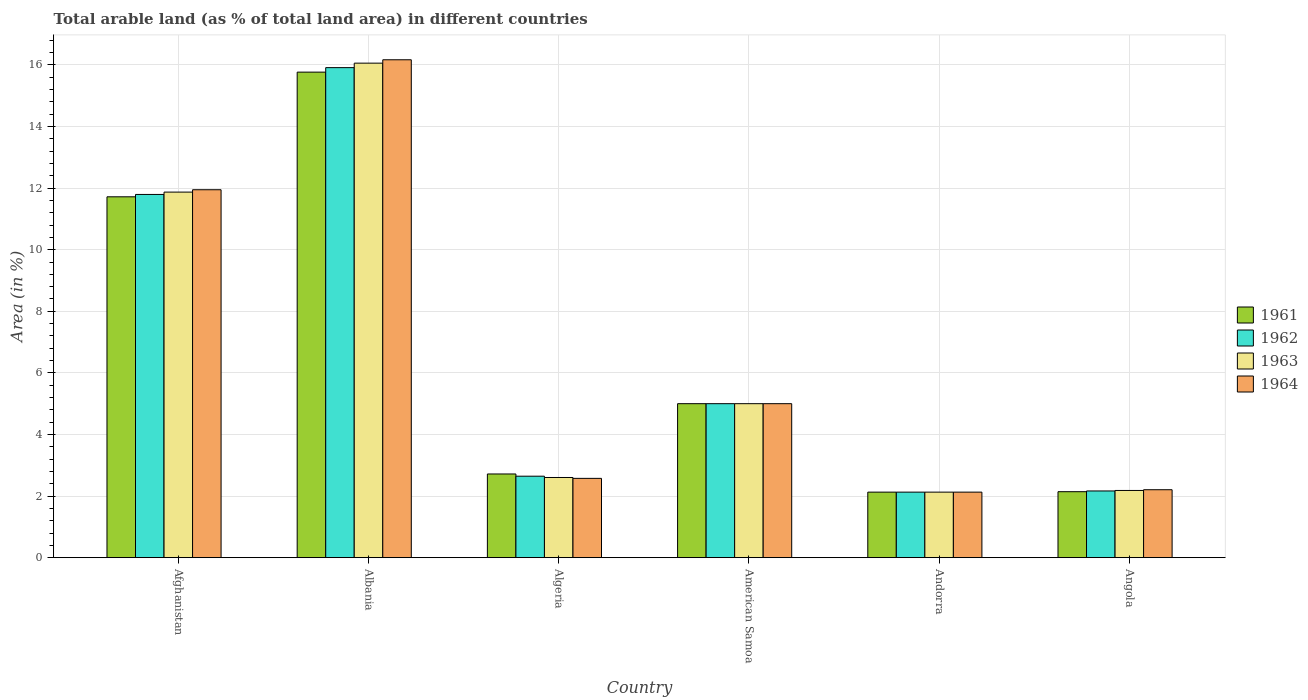How many different coloured bars are there?
Provide a succinct answer. 4. Are the number of bars per tick equal to the number of legend labels?
Give a very brief answer. Yes. How many bars are there on the 6th tick from the left?
Give a very brief answer. 4. How many bars are there on the 4th tick from the right?
Give a very brief answer. 4. What is the label of the 3rd group of bars from the left?
Your answer should be very brief. Algeria. What is the percentage of arable land in 1963 in Angola?
Make the answer very short. 2.18. Across all countries, what is the maximum percentage of arable land in 1962?
Give a very brief answer. 15.91. Across all countries, what is the minimum percentage of arable land in 1964?
Your response must be concise. 2.13. In which country was the percentage of arable land in 1962 maximum?
Offer a very short reply. Albania. In which country was the percentage of arable land in 1961 minimum?
Your answer should be very brief. Andorra. What is the total percentage of arable land in 1962 in the graph?
Provide a short and direct response. 39.65. What is the difference between the percentage of arable land in 1964 in Afghanistan and that in Angola?
Give a very brief answer. 9.74. What is the difference between the percentage of arable land in 1964 in Albania and the percentage of arable land in 1963 in American Samoa?
Give a very brief answer. 11.17. What is the average percentage of arable land in 1963 per country?
Your answer should be compact. 6.64. What is the difference between the percentage of arable land of/in 1964 and percentage of arable land of/in 1963 in Angola?
Ensure brevity in your answer.  0.02. What is the ratio of the percentage of arable land in 1964 in Afghanistan to that in American Samoa?
Keep it short and to the point. 2.39. Is the difference between the percentage of arable land in 1964 in Afghanistan and Andorra greater than the difference between the percentage of arable land in 1963 in Afghanistan and Andorra?
Ensure brevity in your answer.  Yes. What is the difference between the highest and the second highest percentage of arable land in 1962?
Your answer should be compact. 6.79. What is the difference between the highest and the lowest percentage of arable land in 1962?
Provide a succinct answer. 13.78. In how many countries, is the percentage of arable land in 1962 greater than the average percentage of arable land in 1962 taken over all countries?
Your answer should be very brief. 2. What does the 2nd bar from the left in Afghanistan represents?
Offer a terse response. 1962. What does the 1st bar from the right in American Samoa represents?
Ensure brevity in your answer.  1964. Are all the bars in the graph horizontal?
Your answer should be compact. No. What is the difference between two consecutive major ticks on the Y-axis?
Your response must be concise. 2. Are the values on the major ticks of Y-axis written in scientific E-notation?
Provide a succinct answer. No. Does the graph contain any zero values?
Offer a very short reply. No. Where does the legend appear in the graph?
Offer a terse response. Center right. What is the title of the graph?
Offer a very short reply. Total arable land (as % of total land area) in different countries. What is the label or title of the Y-axis?
Offer a very short reply. Area (in %). What is the Area (in %) in 1961 in Afghanistan?
Offer a very short reply. 11.72. What is the Area (in %) of 1962 in Afghanistan?
Ensure brevity in your answer.  11.79. What is the Area (in %) in 1963 in Afghanistan?
Keep it short and to the point. 11.87. What is the Area (in %) of 1964 in Afghanistan?
Offer a very short reply. 11.95. What is the Area (in %) in 1961 in Albania?
Your response must be concise. 15.77. What is the Area (in %) in 1962 in Albania?
Your answer should be very brief. 15.91. What is the Area (in %) in 1963 in Albania?
Your answer should be compact. 16.06. What is the Area (in %) of 1964 in Albania?
Provide a succinct answer. 16.17. What is the Area (in %) in 1961 in Algeria?
Keep it short and to the point. 2.72. What is the Area (in %) in 1962 in Algeria?
Provide a succinct answer. 2.65. What is the Area (in %) in 1963 in Algeria?
Provide a short and direct response. 2.6. What is the Area (in %) of 1964 in Algeria?
Offer a very short reply. 2.57. What is the Area (in %) in 1962 in American Samoa?
Your answer should be compact. 5. What is the Area (in %) of 1963 in American Samoa?
Make the answer very short. 5. What is the Area (in %) in 1961 in Andorra?
Your answer should be very brief. 2.13. What is the Area (in %) in 1962 in Andorra?
Your response must be concise. 2.13. What is the Area (in %) in 1963 in Andorra?
Your answer should be compact. 2.13. What is the Area (in %) in 1964 in Andorra?
Give a very brief answer. 2.13. What is the Area (in %) in 1961 in Angola?
Give a very brief answer. 2.14. What is the Area (in %) in 1962 in Angola?
Provide a short and direct response. 2.17. What is the Area (in %) of 1963 in Angola?
Provide a succinct answer. 2.18. What is the Area (in %) in 1964 in Angola?
Give a very brief answer. 2.21. Across all countries, what is the maximum Area (in %) of 1961?
Ensure brevity in your answer.  15.77. Across all countries, what is the maximum Area (in %) in 1962?
Offer a terse response. 15.91. Across all countries, what is the maximum Area (in %) of 1963?
Keep it short and to the point. 16.06. Across all countries, what is the maximum Area (in %) of 1964?
Offer a terse response. 16.17. Across all countries, what is the minimum Area (in %) in 1961?
Keep it short and to the point. 2.13. Across all countries, what is the minimum Area (in %) in 1962?
Your answer should be very brief. 2.13. Across all countries, what is the minimum Area (in %) of 1963?
Keep it short and to the point. 2.13. Across all countries, what is the minimum Area (in %) in 1964?
Make the answer very short. 2.13. What is the total Area (in %) of 1961 in the graph?
Offer a terse response. 39.47. What is the total Area (in %) in 1962 in the graph?
Ensure brevity in your answer.  39.65. What is the total Area (in %) in 1963 in the graph?
Provide a short and direct response. 39.84. What is the total Area (in %) in 1964 in the graph?
Give a very brief answer. 40.02. What is the difference between the Area (in %) in 1961 in Afghanistan and that in Albania?
Your answer should be very brief. -4.05. What is the difference between the Area (in %) in 1962 in Afghanistan and that in Albania?
Offer a very short reply. -4.12. What is the difference between the Area (in %) in 1963 in Afghanistan and that in Albania?
Provide a short and direct response. -4.19. What is the difference between the Area (in %) of 1964 in Afghanistan and that in Albania?
Provide a short and direct response. -4.22. What is the difference between the Area (in %) in 1961 in Afghanistan and that in Algeria?
Give a very brief answer. 9. What is the difference between the Area (in %) in 1962 in Afghanistan and that in Algeria?
Ensure brevity in your answer.  9.15. What is the difference between the Area (in %) of 1963 in Afghanistan and that in Algeria?
Keep it short and to the point. 9.27. What is the difference between the Area (in %) in 1964 in Afghanistan and that in Algeria?
Offer a very short reply. 9.37. What is the difference between the Area (in %) in 1961 in Afghanistan and that in American Samoa?
Offer a very short reply. 6.72. What is the difference between the Area (in %) in 1962 in Afghanistan and that in American Samoa?
Provide a short and direct response. 6.79. What is the difference between the Area (in %) in 1963 in Afghanistan and that in American Samoa?
Give a very brief answer. 6.87. What is the difference between the Area (in %) of 1964 in Afghanistan and that in American Samoa?
Keep it short and to the point. 6.95. What is the difference between the Area (in %) of 1961 in Afghanistan and that in Andorra?
Your answer should be very brief. 9.59. What is the difference between the Area (in %) of 1962 in Afghanistan and that in Andorra?
Give a very brief answer. 9.67. What is the difference between the Area (in %) of 1963 in Afghanistan and that in Andorra?
Give a very brief answer. 9.74. What is the difference between the Area (in %) in 1964 in Afghanistan and that in Andorra?
Make the answer very short. 9.82. What is the difference between the Area (in %) of 1961 in Afghanistan and that in Angola?
Your answer should be very brief. 9.58. What is the difference between the Area (in %) of 1962 in Afghanistan and that in Angola?
Provide a succinct answer. 9.63. What is the difference between the Area (in %) of 1963 in Afghanistan and that in Angola?
Provide a succinct answer. 9.69. What is the difference between the Area (in %) in 1964 in Afghanistan and that in Angola?
Your answer should be very brief. 9.74. What is the difference between the Area (in %) of 1961 in Albania and that in Algeria?
Provide a succinct answer. 13.05. What is the difference between the Area (in %) in 1962 in Albania and that in Algeria?
Give a very brief answer. 13.27. What is the difference between the Area (in %) of 1963 in Albania and that in Algeria?
Provide a succinct answer. 13.46. What is the difference between the Area (in %) of 1964 in Albania and that in Algeria?
Offer a very short reply. 13.59. What is the difference between the Area (in %) in 1961 in Albania and that in American Samoa?
Provide a short and direct response. 10.77. What is the difference between the Area (in %) of 1962 in Albania and that in American Samoa?
Offer a very short reply. 10.91. What is the difference between the Area (in %) of 1963 in Albania and that in American Samoa?
Give a very brief answer. 11.06. What is the difference between the Area (in %) in 1964 in Albania and that in American Samoa?
Offer a very short reply. 11.17. What is the difference between the Area (in %) in 1961 in Albania and that in Andorra?
Offer a very short reply. 13.64. What is the difference between the Area (in %) of 1962 in Albania and that in Andorra?
Your answer should be very brief. 13.78. What is the difference between the Area (in %) of 1963 in Albania and that in Andorra?
Your answer should be compact. 13.93. What is the difference between the Area (in %) of 1964 in Albania and that in Andorra?
Offer a terse response. 14.04. What is the difference between the Area (in %) of 1961 in Albania and that in Angola?
Give a very brief answer. 13.62. What is the difference between the Area (in %) of 1962 in Albania and that in Angola?
Your response must be concise. 13.75. What is the difference between the Area (in %) of 1963 in Albania and that in Angola?
Your response must be concise. 13.88. What is the difference between the Area (in %) of 1964 in Albania and that in Angola?
Provide a succinct answer. 13.96. What is the difference between the Area (in %) in 1961 in Algeria and that in American Samoa?
Your response must be concise. -2.28. What is the difference between the Area (in %) of 1962 in Algeria and that in American Samoa?
Keep it short and to the point. -2.35. What is the difference between the Area (in %) of 1963 in Algeria and that in American Samoa?
Offer a terse response. -2.4. What is the difference between the Area (in %) of 1964 in Algeria and that in American Samoa?
Your answer should be compact. -2.43. What is the difference between the Area (in %) of 1961 in Algeria and that in Andorra?
Keep it short and to the point. 0.59. What is the difference between the Area (in %) of 1962 in Algeria and that in Andorra?
Provide a short and direct response. 0.52. What is the difference between the Area (in %) of 1963 in Algeria and that in Andorra?
Make the answer very short. 0.48. What is the difference between the Area (in %) of 1964 in Algeria and that in Andorra?
Your response must be concise. 0.45. What is the difference between the Area (in %) in 1961 in Algeria and that in Angola?
Provide a short and direct response. 0.58. What is the difference between the Area (in %) of 1962 in Algeria and that in Angola?
Your answer should be compact. 0.48. What is the difference between the Area (in %) in 1963 in Algeria and that in Angola?
Offer a very short reply. 0.42. What is the difference between the Area (in %) of 1964 in Algeria and that in Angola?
Offer a terse response. 0.37. What is the difference between the Area (in %) in 1961 in American Samoa and that in Andorra?
Make the answer very short. 2.87. What is the difference between the Area (in %) of 1962 in American Samoa and that in Andorra?
Offer a terse response. 2.87. What is the difference between the Area (in %) in 1963 in American Samoa and that in Andorra?
Ensure brevity in your answer.  2.87. What is the difference between the Area (in %) of 1964 in American Samoa and that in Andorra?
Your answer should be very brief. 2.87. What is the difference between the Area (in %) in 1961 in American Samoa and that in Angola?
Make the answer very short. 2.86. What is the difference between the Area (in %) in 1962 in American Samoa and that in Angola?
Your response must be concise. 2.83. What is the difference between the Area (in %) in 1963 in American Samoa and that in Angola?
Offer a very short reply. 2.82. What is the difference between the Area (in %) of 1964 in American Samoa and that in Angola?
Make the answer very short. 2.79. What is the difference between the Area (in %) in 1961 in Andorra and that in Angola?
Provide a succinct answer. -0.01. What is the difference between the Area (in %) in 1962 in Andorra and that in Angola?
Your answer should be compact. -0.04. What is the difference between the Area (in %) in 1963 in Andorra and that in Angola?
Make the answer very short. -0.05. What is the difference between the Area (in %) of 1964 in Andorra and that in Angola?
Give a very brief answer. -0.08. What is the difference between the Area (in %) in 1961 in Afghanistan and the Area (in %) in 1962 in Albania?
Keep it short and to the point. -4.19. What is the difference between the Area (in %) in 1961 in Afghanistan and the Area (in %) in 1963 in Albania?
Make the answer very short. -4.34. What is the difference between the Area (in %) in 1961 in Afghanistan and the Area (in %) in 1964 in Albania?
Your answer should be very brief. -4.45. What is the difference between the Area (in %) in 1962 in Afghanistan and the Area (in %) in 1963 in Albania?
Keep it short and to the point. -4.26. What is the difference between the Area (in %) of 1962 in Afghanistan and the Area (in %) of 1964 in Albania?
Provide a short and direct response. -4.37. What is the difference between the Area (in %) in 1963 in Afghanistan and the Area (in %) in 1964 in Albania?
Your response must be concise. -4.3. What is the difference between the Area (in %) of 1961 in Afghanistan and the Area (in %) of 1962 in Algeria?
Provide a short and direct response. 9.07. What is the difference between the Area (in %) in 1961 in Afghanistan and the Area (in %) in 1963 in Algeria?
Make the answer very short. 9.11. What is the difference between the Area (in %) of 1961 in Afghanistan and the Area (in %) of 1964 in Algeria?
Your answer should be very brief. 9.14. What is the difference between the Area (in %) of 1962 in Afghanistan and the Area (in %) of 1963 in Algeria?
Offer a terse response. 9.19. What is the difference between the Area (in %) in 1962 in Afghanistan and the Area (in %) in 1964 in Algeria?
Make the answer very short. 9.22. What is the difference between the Area (in %) of 1963 in Afghanistan and the Area (in %) of 1964 in Algeria?
Keep it short and to the point. 9.3. What is the difference between the Area (in %) in 1961 in Afghanistan and the Area (in %) in 1962 in American Samoa?
Offer a terse response. 6.72. What is the difference between the Area (in %) of 1961 in Afghanistan and the Area (in %) of 1963 in American Samoa?
Offer a terse response. 6.72. What is the difference between the Area (in %) of 1961 in Afghanistan and the Area (in %) of 1964 in American Samoa?
Provide a short and direct response. 6.72. What is the difference between the Area (in %) of 1962 in Afghanistan and the Area (in %) of 1963 in American Samoa?
Your answer should be very brief. 6.79. What is the difference between the Area (in %) of 1962 in Afghanistan and the Area (in %) of 1964 in American Samoa?
Your answer should be very brief. 6.79. What is the difference between the Area (in %) of 1963 in Afghanistan and the Area (in %) of 1964 in American Samoa?
Make the answer very short. 6.87. What is the difference between the Area (in %) in 1961 in Afghanistan and the Area (in %) in 1962 in Andorra?
Ensure brevity in your answer.  9.59. What is the difference between the Area (in %) in 1961 in Afghanistan and the Area (in %) in 1963 in Andorra?
Ensure brevity in your answer.  9.59. What is the difference between the Area (in %) in 1961 in Afghanistan and the Area (in %) in 1964 in Andorra?
Your answer should be compact. 9.59. What is the difference between the Area (in %) in 1962 in Afghanistan and the Area (in %) in 1963 in Andorra?
Offer a terse response. 9.67. What is the difference between the Area (in %) in 1962 in Afghanistan and the Area (in %) in 1964 in Andorra?
Make the answer very short. 9.67. What is the difference between the Area (in %) in 1963 in Afghanistan and the Area (in %) in 1964 in Andorra?
Offer a terse response. 9.74. What is the difference between the Area (in %) in 1961 in Afghanistan and the Area (in %) in 1962 in Angola?
Provide a succinct answer. 9.55. What is the difference between the Area (in %) in 1961 in Afghanistan and the Area (in %) in 1963 in Angola?
Your answer should be compact. 9.54. What is the difference between the Area (in %) in 1961 in Afghanistan and the Area (in %) in 1964 in Angola?
Your answer should be very brief. 9.51. What is the difference between the Area (in %) of 1962 in Afghanistan and the Area (in %) of 1963 in Angola?
Your answer should be compact. 9.61. What is the difference between the Area (in %) in 1962 in Afghanistan and the Area (in %) in 1964 in Angola?
Keep it short and to the point. 9.59. What is the difference between the Area (in %) of 1963 in Afghanistan and the Area (in %) of 1964 in Angola?
Your answer should be very brief. 9.66. What is the difference between the Area (in %) in 1961 in Albania and the Area (in %) in 1962 in Algeria?
Provide a short and direct response. 13.12. What is the difference between the Area (in %) in 1961 in Albania and the Area (in %) in 1963 in Algeria?
Offer a terse response. 13.16. What is the difference between the Area (in %) of 1961 in Albania and the Area (in %) of 1964 in Algeria?
Provide a short and direct response. 13.19. What is the difference between the Area (in %) in 1962 in Albania and the Area (in %) in 1963 in Algeria?
Your response must be concise. 13.31. What is the difference between the Area (in %) of 1962 in Albania and the Area (in %) of 1964 in Algeria?
Your answer should be very brief. 13.34. What is the difference between the Area (in %) of 1963 in Albania and the Area (in %) of 1964 in Algeria?
Keep it short and to the point. 13.48. What is the difference between the Area (in %) in 1961 in Albania and the Area (in %) in 1962 in American Samoa?
Your answer should be very brief. 10.77. What is the difference between the Area (in %) in 1961 in Albania and the Area (in %) in 1963 in American Samoa?
Your response must be concise. 10.77. What is the difference between the Area (in %) in 1961 in Albania and the Area (in %) in 1964 in American Samoa?
Keep it short and to the point. 10.77. What is the difference between the Area (in %) of 1962 in Albania and the Area (in %) of 1963 in American Samoa?
Ensure brevity in your answer.  10.91. What is the difference between the Area (in %) of 1962 in Albania and the Area (in %) of 1964 in American Samoa?
Make the answer very short. 10.91. What is the difference between the Area (in %) in 1963 in Albania and the Area (in %) in 1964 in American Samoa?
Provide a short and direct response. 11.06. What is the difference between the Area (in %) of 1961 in Albania and the Area (in %) of 1962 in Andorra?
Your answer should be very brief. 13.64. What is the difference between the Area (in %) of 1961 in Albania and the Area (in %) of 1963 in Andorra?
Your answer should be very brief. 13.64. What is the difference between the Area (in %) in 1961 in Albania and the Area (in %) in 1964 in Andorra?
Provide a short and direct response. 13.64. What is the difference between the Area (in %) of 1962 in Albania and the Area (in %) of 1963 in Andorra?
Keep it short and to the point. 13.78. What is the difference between the Area (in %) in 1962 in Albania and the Area (in %) in 1964 in Andorra?
Ensure brevity in your answer.  13.78. What is the difference between the Area (in %) of 1963 in Albania and the Area (in %) of 1964 in Andorra?
Your answer should be very brief. 13.93. What is the difference between the Area (in %) of 1961 in Albania and the Area (in %) of 1962 in Angola?
Provide a succinct answer. 13.6. What is the difference between the Area (in %) of 1961 in Albania and the Area (in %) of 1963 in Angola?
Keep it short and to the point. 13.58. What is the difference between the Area (in %) in 1961 in Albania and the Area (in %) in 1964 in Angola?
Give a very brief answer. 13.56. What is the difference between the Area (in %) of 1962 in Albania and the Area (in %) of 1963 in Angola?
Keep it short and to the point. 13.73. What is the difference between the Area (in %) in 1962 in Albania and the Area (in %) in 1964 in Angola?
Give a very brief answer. 13.71. What is the difference between the Area (in %) of 1963 in Albania and the Area (in %) of 1964 in Angola?
Offer a terse response. 13.85. What is the difference between the Area (in %) of 1961 in Algeria and the Area (in %) of 1962 in American Samoa?
Keep it short and to the point. -2.28. What is the difference between the Area (in %) in 1961 in Algeria and the Area (in %) in 1963 in American Samoa?
Keep it short and to the point. -2.28. What is the difference between the Area (in %) of 1961 in Algeria and the Area (in %) of 1964 in American Samoa?
Provide a short and direct response. -2.28. What is the difference between the Area (in %) in 1962 in Algeria and the Area (in %) in 1963 in American Samoa?
Your response must be concise. -2.35. What is the difference between the Area (in %) of 1962 in Algeria and the Area (in %) of 1964 in American Samoa?
Give a very brief answer. -2.35. What is the difference between the Area (in %) of 1963 in Algeria and the Area (in %) of 1964 in American Samoa?
Offer a very short reply. -2.4. What is the difference between the Area (in %) in 1961 in Algeria and the Area (in %) in 1962 in Andorra?
Provide a succinct answer. 0.59. What is the difference between the Area (in %) in 1961 in Algeria and the Area (in %) in 1963 in Andorra?
Give a very brief answer. 0.59. What is the difference between the Area (in %) of 1961 in Algeria and the Area (in %) of 1964 in Andorra?
Your response must be concise. 0.59. What is the difference between the Area (in %) of 1962 in Algeria and the Area (in %) of 1963 in Andorra?
Keep it short and to the point. 0.52. What is the difference between the Area (in %) of 1962 in Algeria and the Area (in %) of 1964 in Andorra?
Offer a terse response. 0.52. What is the difference between the Area (in %) of 1963 in Algeria and the Area (in %) of 1964 in Andorra?
Give a very brief answer. 0.48. What is the difference between the Area (in %) of 1961 in Algeria and the Area (in %) of 1962 in Angola?
Ensure brevity in your answer.  0.55. What is the difference between the Area (in %) of 1961 in Algeria and the Area (in %) of 1963 in Angola?
Provide a short and direct response. 0.54. What is the difference between the Area (in %) in 1961 in Algeria and the Area (in %) in 1964 in Angola?
Keep it short and to the point. 0.51. What is the difference between the Area (in %) in 1962 in Algeria and the Area (in %) in 1963 in Angola?
Provide a short and direct response. 0.46. What is the difference between the Area (in %) in 1962 in Algeria and the Area (in %) in 1964 in Angola?
Ensure brevity in your answer.  0.44. What is the difference between the Area (in %) of 1963 in Algeria and the Area (in %) of 1964 in Angola?
Keep it short and to the point. 0.4. What is the difference between the Area (in %) in 1961 in American Samoa and the Area (in %) in 1962 in Andorra?
Offer a very short reply. 2.87. What is the difference between the Area (in %) of 1961 in American Samoa and the Area (in %) of 1963 in Andorra?
Provide a short and direct response. 2.87. What is the difference between the Area (in %) of 1961 in American Samoa and the Area (in %) of 1964 in Andorra?
Your response must be concise. 2.87. What is the difference between the Area (in %) in 1962 in American Samoa and the Area (in %) in 1963 in Andorra?
Your answer should be very brief. 2.87. What is the difference between the Area (in %) of 1962 in American Samoa and the Area (in %) of 1964 in Andorra?
Keep it short and to the point. 2.87. What is the difference between the Area (in %) of 1963 in American Samoa and the Area (in %) of 1964 in Andorra?
Your answer should be compact. 2.87. What is the difference between the Area (in %) in 1961 in American Samoa and the Area (in %) in 1962 in Angola?
Offer a very short reply. 2.83. What is the difference between the Area (in %) of 1961 in American Samoa and the Area (in %) of 1963 in Angola?
Give a very brief answer. 2.82. What is the difference between the Area (in %) of 1961 in American Samoa and the Area (in %) of 1964 in Angola?
Your response must be concise. 2.79. What is the difference between the Area (in %) of 1962 in American Samoa and the Area (in %) of 1963 in Angola?
Keep it short and to the point. 2.82. What is the difference between the Area (in %) of 1962 in American Samoa and the Area (in %) of 1964 in Angola?
Provide a succinct answer. 2.79. What is the difference between the Area (in %) of 1963 in American Samoa and the Area (in %) of 1964 in Angola?
Offer a very short reply. 2.79. What is the difference between the Area (in %) in 1961 in Andorra and the Area (in %) in 1962 in Angola?
Make the answer very short. -0.04. What is the difference between the Area (in %) of 1961 in Andorra and the Area (in %) of 1963 in Angola?
Give a very brief answer. -0.05. What is the difference between the Area (in %) in 1961 in Andorra and the Area (in %) in 1964 in Angola?
Offer a terse response. -0.08. What is the difference between the Area (in %) of 1962 in Andorra and the Area (in %) of 1963 in Angola?
Provide a short and direct response. -0.05. What is the difference between the Area (in %) of 1962 in Andorra and the Area (in %) of 1964 in Angola?
Your answer should be compact. -0.08. What is the difference between the Area (in %) in 1963 in Andorra and the Area (in %) in 1964 in Angola?
Offer a terse response. -0.08. What is the average Area (in %) in 1961 per country?
Give a very brief answer. 6.58. What is the average Area (in %) in 1962 per country?
Provide a short and direct response. 6.61. What is the average Area (in %) in 1963 per country?
Offer a very short reply. 6.64. What is the average Area (in %) in 1964 per country?
Keep it short and to the point. 6.67. What is the difference between the Area (in %) of 1961 and Area (in %) of 1962 in Afghanistan?
Give a very brief answer. -0.08. What is the difference between the Area (in %) in 1961 and Area (in %) in 1963 in Afghanistan?
Offer a very short reply. -0.15. What is the difference between the Area (in %) of 1961 and Area (in %) of 1964 in Afghanistan?
Keep it short and to the point. -0.23. What is the difference between the Area (in %) in 1962 and Area (in %) in 1963 in Afghanistan?
Give a very brief answer. -0.08. What is the difference between the Area (in %) of 1962 and Area (in %) of 1964 in Afghanistan?
Provide a succinct answer. -0.15. What is the difference between the Area (in %) of 1963 and Area (in %) of 1964 in Afghanistan?
Your answer should be compact. -0.08. What is the difference between the Area (in %) of 1961 and Area (in %) of 1962 in Albania?
Your response must be concise. -0.15. What is the difference between the Area (in %) in 1961 and Area (in %) in 1963 in Albania?
Ensure brevity in your answer.  -0.29. What is the difference between the Area (in %) in 1961 and Area (in %) in 1964 in Albania?
Provide a short and direct response. -0.4. What is the difference between the Area (in %) of 1962 and Area (in %) of 1963 in Albania?
Your response must be concise. -0.15. What is the difference between the Area (in %) of 1962 and Area (in %) of 1964 in Albania?
Make the answer very short. -0.26. What is the difference between the Area (in %) in 1963 and Area (in %) in 1964 in Albania?
Make the answer very short. -0.11. What is the difference between the Area (in %) of 1961 and Area (in %) of 1962 in Algeria?
Provide a short and direct response. 0.07. What is the difference between the Area (in %) of 1961 and Area (in %) of 1963 in Algeria?
Provide a succinct answer. 0.11. What is the difference between the Area (in %) in 1961 and Area (in %) in 1964 in Algeria?
Offer a terse response. 0.14. What is the difference between the Area (in %) in 1962 and Area (in %) in 1963 in Algeria?
Offer a very short reply. 0.04. What is the difference between the Area (in %) in 1962 and Area (in %) in 1964 in Algeria?
Provide a succinct answer. 0.07. What is the difference between the Area (in %) in 1963 and Area (in %) in 1964 in Algeria?
Provide a short and direct response. 0.03. What is the difference between the Area (in %) of 1961 and Area (in %) of 1963 in American Samoa?
Provide a short and direct response. 0. What is the difference between the Area (in %) in 1961 and Area (in %) in 1964 in American Samoa?
Provide a short and direct response. 0. What is the difference between the Area (in %) of 1961 and Area (in %) of 1962 in Andorra?
Ensure brevity in your answer.  0. What is the difference between the Area (in %) of 1961 and Area (in %) of 1963 in Andorra?
Make the answer very short. 0. What is the difference between the Area (in %) in 1961 and Area (in %) in 1964 in Andorra?
Provide a short and direct response. 0. What is the difference between the Area (in %) in 1962 and Area (in %) in 1963 in Andorra?
Ensure brevity in your answer.  0. What is the difference between the Area (in %) in 1963 and Area (in %) in 1964 in Andorra?
Give a very brief answer. 0. What is the difference between the Area (in %) in 1961 and Area (in %) in 1962 in Angola?
Offer a very short reply. -0.02. What is the difference between the Area (in %) of 1961 and Area (in %) of 1963 in Angola?
Your answer should be compact. -0.04. What is the difference between the Area (in %) of 1961 and Area (in %) of 1964 in Angola?
Give a very brief answer. -0.06. What is the difference between the Area (in %) of 1962 and Area (in %) of 1963 in Angola?
Your answer should be compact. -0.02. What is the difference between the Area (in %) in 1962 and Area (in %) in 1964 in Angola?
Make the answer very short. -0.04. What is the difference between the Area (in %) of 1963 and Area (in %) of 1964 in Angola?
Provide a short and direct response. -0.02. What is the ratio of the Area (in %) of 1961 in Afghanistan to that in Albania?
Your answer should be compact. 0.74. What is the ratio of the Area (in %) in 1962 in Afghanistan to that in Albania?
Give a very brief answer. 0.74. What is the ratio of the Area (in %) of 1963 in Afghanistan to that in Albania?
Your answer should be very brief. 0.74. What is the ratio of the Area (in %) of 1964 in Afghanistan to that in Albania?
Keep it short and to the point. 0.74. What is the ratio of the Area (in %) in 1961 in Afghanistan to that in Algeria?
Ensure brevity in your answer.  4.31. What is the ratio of the Area (in %) in 1962 in Afghanistan to that in Algeria?
Offer a very short reply. 4.46. What is the ratio of the Area (in %) of 1963 in Afghanistan to that in Algeria?
Provide a short and direct response. 4.56. What is the ratio of the Area (in %) of 1964 in Afghanistan to that in Algeria?
Offer a terse response. 4.64. What is the ratio of the Area (in %) of 1961 in Afghanistan to that in American Samoa?
Provide a short and direct response. 2.34. What is the ratio of the Area (in %) of 1962 in Afghanistan to that in American Samoa?
Your answer should be very brief. 2.36. What is the ratio of the Area (in %) of 1963 in Afghanistan to that in American Samoa?
Provide a succinct answer. 2.37. What is the ratio of the Area (in %) in 1964 in Afghanistan to that in American Samoa?
Offer a terse response. 2.39. What is the ratio of the Area (in %) of 1961 in Afghanistan to that in Andorra?
Your response must be concise. 5.51. What is the ratio of the Area (in %) of 1962 in Afghanistan to that in Andorra?
Keep it short and to the point. 5.54. What is the ratio of the Area (in %) in 1963 in Afghanistan to that in Andorra?
Keep it short and to the point. 5.58. What is the ratio of the Area (in %) of 1964 in Afghanistan to that in Andorra?
Your response must be concise. 5.62. What is the ratio of the Area (in %) of 1961 in Afghanistan to that in Angola?
Ensure brevity in your answer.  5.47. What is the ratio of the Area (in %) of 1962 in Afghanistan to that in Angola?
Ensure brevity in your answer.  5.45. What is the ratio of the Area (in %) of 1963 in Afghanistan to that in Angola?
Your response must be concise. 5.44. What is the ratio of the Area (in %) in 1964 in Afghanistan to that in Angola?
Ensure brevity in your answer.  5.42. What is the ratio of the Area (in %) of 1961 in Albania to that in Algeria?
Your response must be concise. 5.8. What is the ratio of the Area (in %) in 1962 in Albania to that in Algeria?
Ensure brevity in your answer.  6.02. What is the ratio of the Area (in %) of 1963 in Albania to that in Algeria?
Your answer should be compact. 6.17. What is the ratio of the Area (in %) in 1964 in Albania to that in Algeria?
Keep it short and to the point. 6.28. What is the ratio of the Area (in %) of 1961 in Albania to that in American Samoa?
Give a very brief answer. 3.15. What is the ratio of the Area (in %) in 1962 in Albania to that in American Samoa?
Your answer should be compact. 3.18. What is the ratio of the Area (in %) in 1963 in Albania to that in American Samoa?
Offer a very short reply. 3.21. What is the ratio of the Area (in %) of 1964 in Albania to that in American Samoa?
Ensure brevity in your answer.  3.23. What is the ratio of the Area (in %) of 1961 in Albania to that in Andorra?
Ensure brevity in your answer.  7.41. What is the ratio of the Area (in %) in 1962 in Albania to that in Andorra?
Your response must be concise. 7.48. What is the ratio of the Area (in %) in 1963 in Albania to that in Andorra?
Your answer should be very brief. 7.55. What is the ratio of the Area (in %) in 1964 in Albania to that in Andorra?
Keep it short and to the point. 7.6. What is the ratio of the Area (in %) of 1961 in Albania to that in Angola?
Your answer should be compact. 7.36. What is the ratio of the Area (in %) in 1962 in Albania to that in Angola?
Your answer should be very brief. 7.35. What is the ratio of the Area (in %) in 1963 in Albania to that in Angola?
Your answer should be very brief. 7.36. What is the ratio of the Area (in %) in 1964 in Albania to that in Angola?
Offer a terse response. 7.33. What is the ratio of the Area (in %) in 1961 in Algeria to that in American Samoa?
Give a very brief answer. 0.54. What is the ratio of the Area (in %) in 1962 in Algeria to that in American Samoa?
Offer a very short reply. 0.53. What is the ratio of the Area (in %) of 1963 in Algeria to that in American Samoa?
Give a very brief answer. 0.52. What is the ratio of the Area (in %) in 1964 in Algeria to that in American Samoa?
Your response must be concise. 0.51. What is the ratio of the Area (in %) in 1961 in Algeria to that in Andorra?
Offer a terse response. 1.28. What is the ratio of the Area (in %) of 1962 in Algeria to that in Andorra?
Your answer should be compact. 1.24. What is the ratio of the Area (in %) in 1963 in Algeria to that in Andorra?
Your response must be concise. 1.22. What is the ratio of the Area (in %) of 1964 in Algeria to that in Andorra?
Offer a very short reply. 1.21. What is the ratio of the Area (in %) in 1961 in Algeria to that in Angola?
Provide a succinct answer. 1.27. What is the ratio of the Area (in %) of 1962 in Algeria to that in Angola?
Your answer should be very brief. 1.22. What is the ratio of the Area (in %) in 1963 in Algeria to that in Angola?
Your answer should be compact. 1.19. What is the ratio of the Area (in %) of 1964 in Algeria to that in Angola?
Keep it short and to the point. 1.17. What is the ratio of the Area (in %) of 1961 in American Samoa to that in Andorra?
Offer a terse response. 2.35. What is the ratio of the Area (in %) of 1962 in American Samoa to that in Andorra?
Your response must be concise. 2.35. What is the ratio of the Area (in %) of 1963 in American Samoa to that in Andorra?
Make the answer very short. 2.35. What is the ratio of the Area (in %) in 1964 in American Samoa to that in Andorra?
Offer a very short reply. 2.35. What is the ratio of the Area (in %) of 1961 in American Samoa to that in Angola?
Offer a very short reply. 2.33. What is the ratio of the Area (in %) in 1962 in American Samoa to that in Angola?
Ensure brevity in your answer.  2.31. What is the ratio of the Area (in %) in 1963 in American Samoa to that in Angola?
Keep it short and to the point. 2.29. What is the ratio of the Area (in %) of 1964 in American Samoa to that in Angola?
Ensure brevity in your answer.  2.27. What is the ratio of the Area (in %) of 1961 in Andorra to that in Angola?
Offer a very short reply. 0.99. What is the ratio of the Area (in %) of 1962 in Andorra to that in Angola?
Provide a short and direct response. 0.98. What is the ratio of the Area (in %) of 1963 in Andorra to that in Angola?
Ensure brevity in your answer.  0.98. What is the ratio of the Area (in %) in 1964 in Andorra to that in Angola?
Your response must be concise. 0.96. What is the difference between the highest and the second highest Area (in %) of 1961?
Provide a short and direct response. 4.05. What is the difference between the highest and the second highest Area (in %) of 1962?
Provide a succinct answer. 4.12. What is the difference between the highest and the second highest Area (in %) of 1963?
Ensure brevity in your answer.  4.19. What is the difference between the highest and the second highest Area (in %) of 1964?
Give a very brief answer. 4.22. What is the difference between the highest and the lowest Area (in %) in 1961?
Your answer should be very brief. 13.64. What is the difference between the highest and the lowest Area (in %) of 1962?
Give a very brief answer. 13.78. What is the difference between the highest and the lowest Area (in %) in 1963?
Your answer should be compact. 13.93. What is the difference between the highest and the lowest Area (in %) in 1964?
Offer a very short reply. 14.04. 